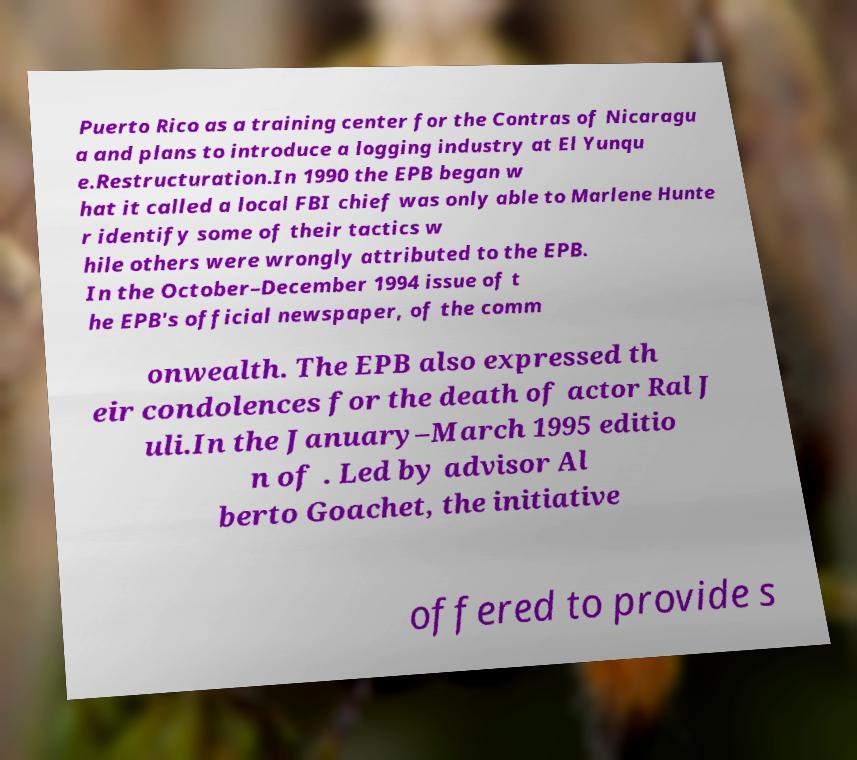Please identify and transcribe the text found in this image. Puerto Rico as a training center for the Contras of Nicaragu a and plans to introduce a logging industry at El Yunqu e.Restructuration.In 1990 the EPB began w hat it called a local FBI chief was only able to Marlene Hunte r identify some of their tactics w hile others were wrongly attributed to the EPB. In the October–December 1994 issue of t he EPB's official newspaper, of the comm onwealth. The EPB also expressed th eir condolences for the death of actor Ral J uli.In the January–March 1995 editio n of . Led by advisor Al berto Goachet, the initiative offered to provide s 